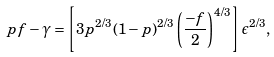Convert formula to latex. <formula><loc_0><loc_0><loc_500><loc_500>p f - \gamma = \left [ 3 p ^ { 2 / 3 } ( 1 - p ) ^ { 2 / 3 } \left ( \frac { - f } { 2 } \right ) ^ { 4 / 3 } \right ] \epsilon ^ { 2 / 3 } ,</formula> 